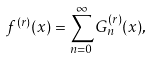Convert formula to latex. <formula><loc_0><loc_0><loc_500><loc_500>f ^ { ( r ) } ( x ) = \sum _ { n = 0 } ^ { \infty } G _ { n } ^ { ( r ) } ( x ) ,</formula> 